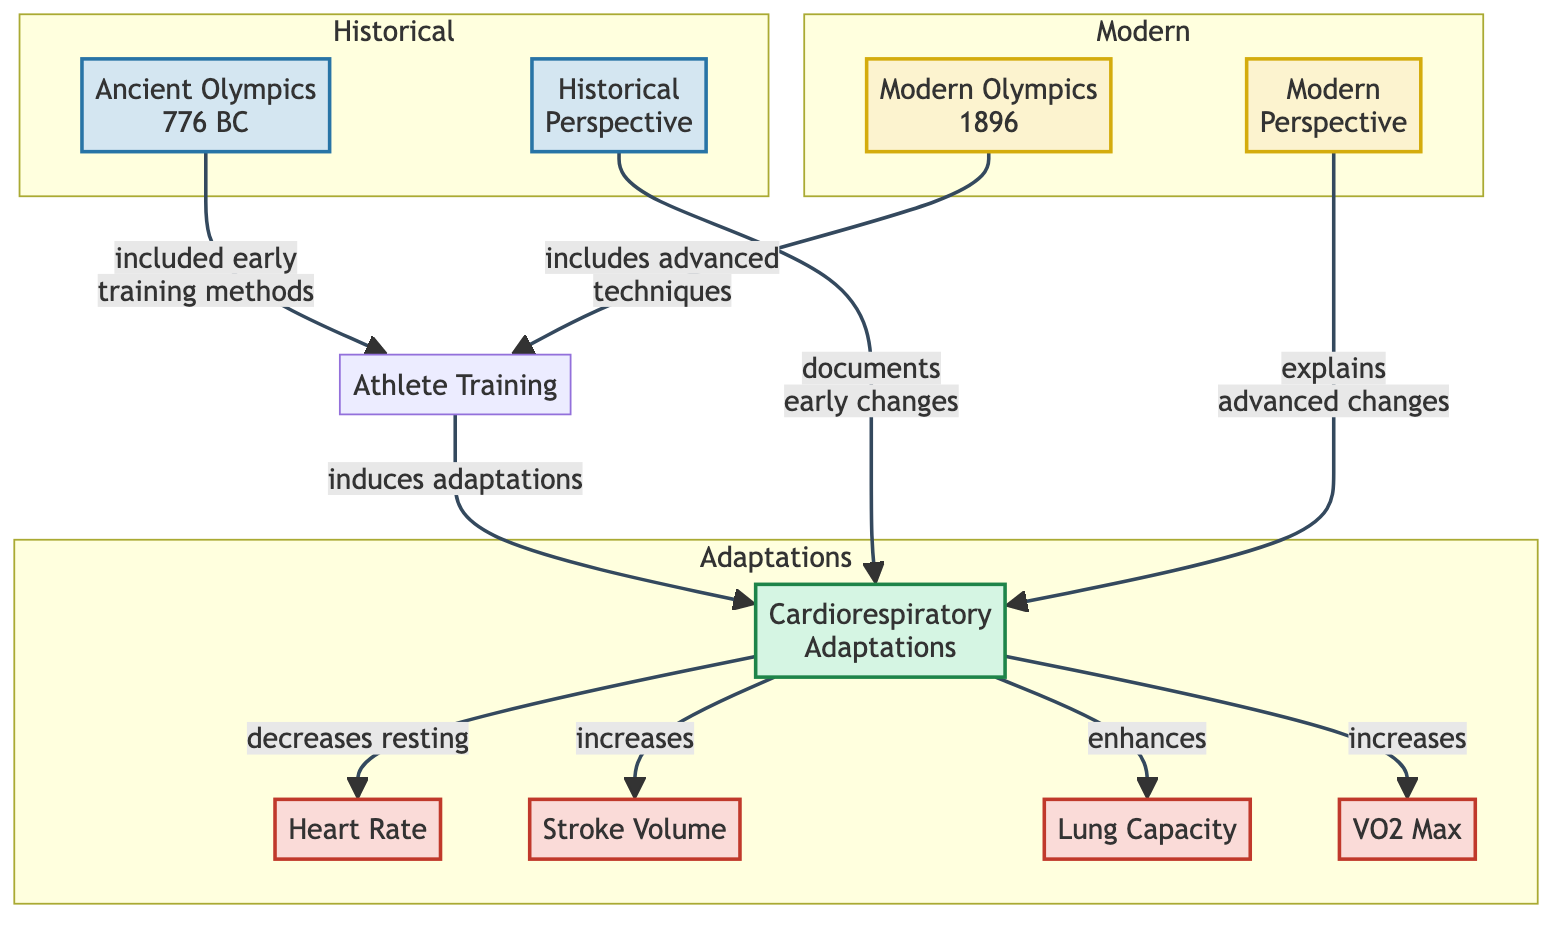What are the early training methods included in the historical perspective? The diagram indicates that the Ancient Olympics (776 BC) included early training methods that influenced athlete training. This is shown by the connection from Ancient Olympics to Athlete Training.
Answer: early training methods How does the modern perspective explain changes in cardiorespiratory adaptations? The diagram states that the modern perspective explains advanced changes in cardiorespiratory adaptations, as indicated by the link between Modern Perspective and Cardiorespiratory Adaptations.
Answer: advanced changes What does Athlete Training induce? According to the diagram, Athlete Training induces cardiorespiratory adaptations, which is directly stated as an outcome from Athlete Training to Cardiorespiratory Adaptations.
Answer: adaptations Which measure is enhanced by cardiorespiratory adaptations? The diagram shows a direct relationship indicating that cardiopulmonary adaptations enhance lung capacity as one of the specific adaptations resulting from athlete training.
Answer: lung capacity What is the relationship between Ancient Olympics and Athlete Training? The diagram presents a link between Ancient Olympics and Athlete Training, where the relationship is described as "included early training methods."
Answer: included early training methods What are the adaptations indicated in the diagram? The diagram presents five specific adaptations related to cardiorespiratory fitness, showing the connections to Stroke Volume, Heart Rate, Lung Capacity, and VO2 Max.
Answer: Heart Rate, Stroke Volume, Lung Capacity, VO2 Max How many nodes represent historical perspectives in the diagram? The diagram includes two nodes representing historical perspectives: Ancient Olympics and Historical Perspective, which can be counted visually.
Answer: 2 